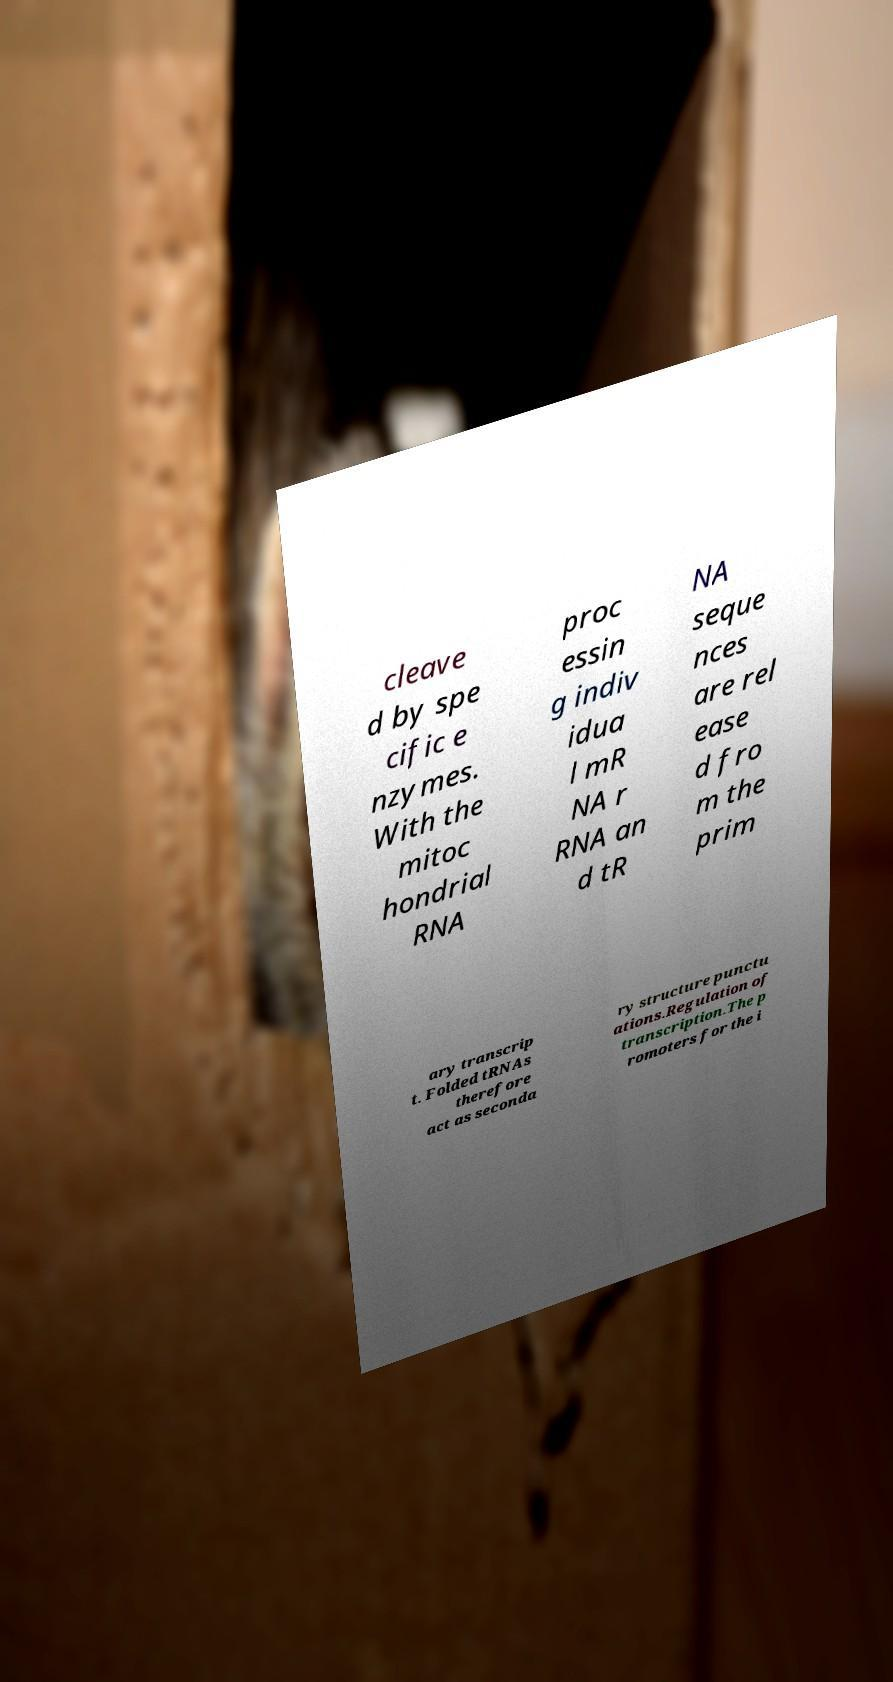For documentation purposes, I need the text within this image transcribed. Could you provide that? cleave d by spe cific e nzymes. With the mitoc hondrial RNA proc essin g indiv idua l mR NA r RNA an d tR NA seque nces are rel ease d fro m the prim ary transcrip t. Folded tRNAs therefore act as seconda ry structure punctu ations.Regulation of transcription.The p romoters for the i 